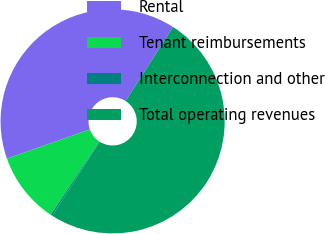Convert chart to OTSL. <chart><loc_0><loc_0><loc_500><loc_500><pie_chart><fcel>Rental<fcel>Tenant reimbursements<fcel>Interconnection and other<fcel>Total operating revenues<nl><fcel>39.46%<fcel>10.29%<fcel>0.25%<fcel>50.0%<nl></chart> 